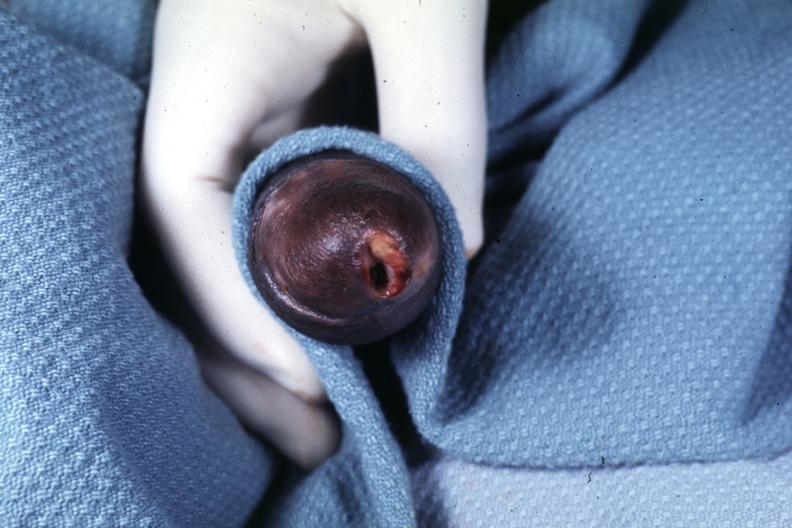does parathyroid show glans ulcer probable herpes?
Answer the question using a single word or phrase. No 